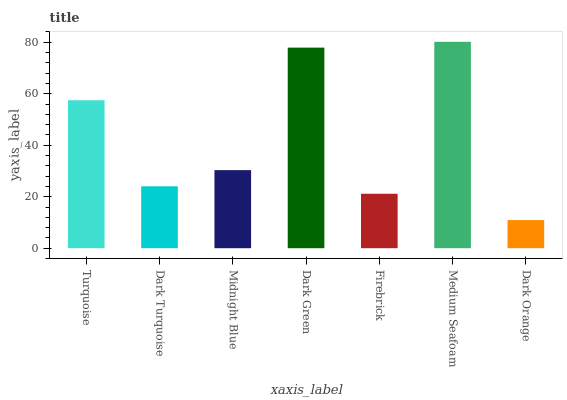Is Dark Turquoise the minimum?
Answer yes or no. No. Is Dark Turquoise the maximum?
Answer yes or no. No. Is Turquoise greater than Dark Turquoise?
Answer yes or no. Yes. Is Dark Turquoise less than Turquoise?
Answer yes or no. Yes. Is Dark Turquoise greater than Turquoise?
Answer yes or no. No. Is Turquoise less than Dark Turquoise?
Answer yes or no. No. Is Midnight Blue the high median?
Answer yes or no. Yes. Is Midnight Blue the low median?
Answer yes or no. Yes. Is Dark Orange the high median?
Answer yes or no. No. Is Dark Green the low median?
Answer yes or no. No. 